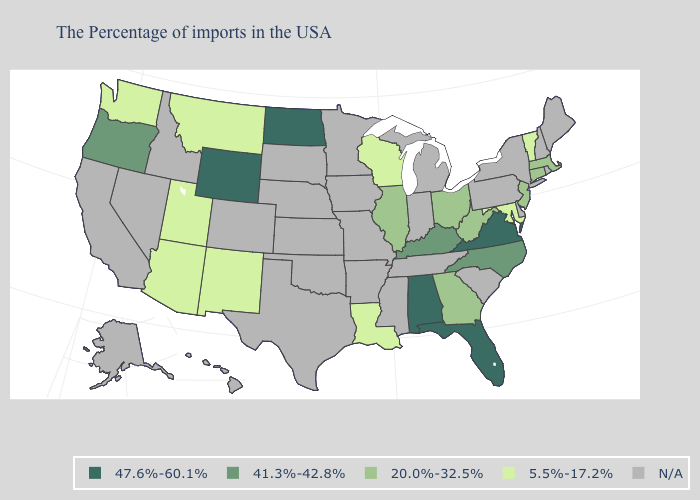Among the states that border Virginia , which have the highest value?
Quick response, please. North Carolina, Kentucky. Which states hav the highest value in the West?
Keep it brief. Wyoming. What is the lowest value in the West?
Give a very brief answer. 5.5%-17.2%. What is the value of Maryland?
Short answer required. 5.5%-17.2%. Which states have the lowest value in the USA?
Give a very brief answer. Vermont, Maryland, Wisconsin, Louisiana, New Mexico, Utah, Montana, Arizona, Washington. What is the lowest value in the Northeast?
Quick response, please. 5.5%-17.2%. What is the highest value in the Northeast ?
Give a very brief answer. 20.0%-32.5%. What is the value of New Mexico?
Quick response, please. 5.5%-17.2%. Among the states that border Delaware , which have the highest value?
Be succinct. New Jersey. Name the states that have a value in the range 20.0%-32.5%?
Quick response, please. Massachusetts, Connecticut, New Jersey, West Virginia, Ohio, Georgia, Illinois. What is the lowest value in the USA?
Be succinct. 5.5%-17.2%. 